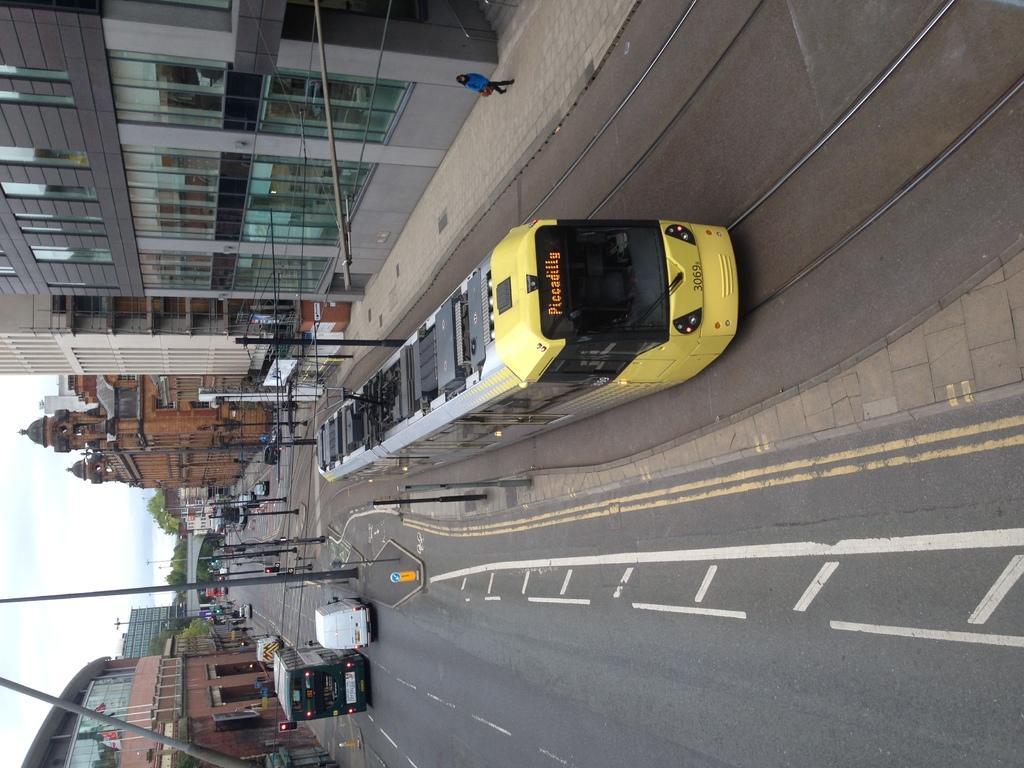How would you summarize this image in a sentence or two? In this picture we can see a train on a railway track, vehicles on the road, poles, buildings, trees and a person walking on the footpath and some objects and in the background we can see the sky. 